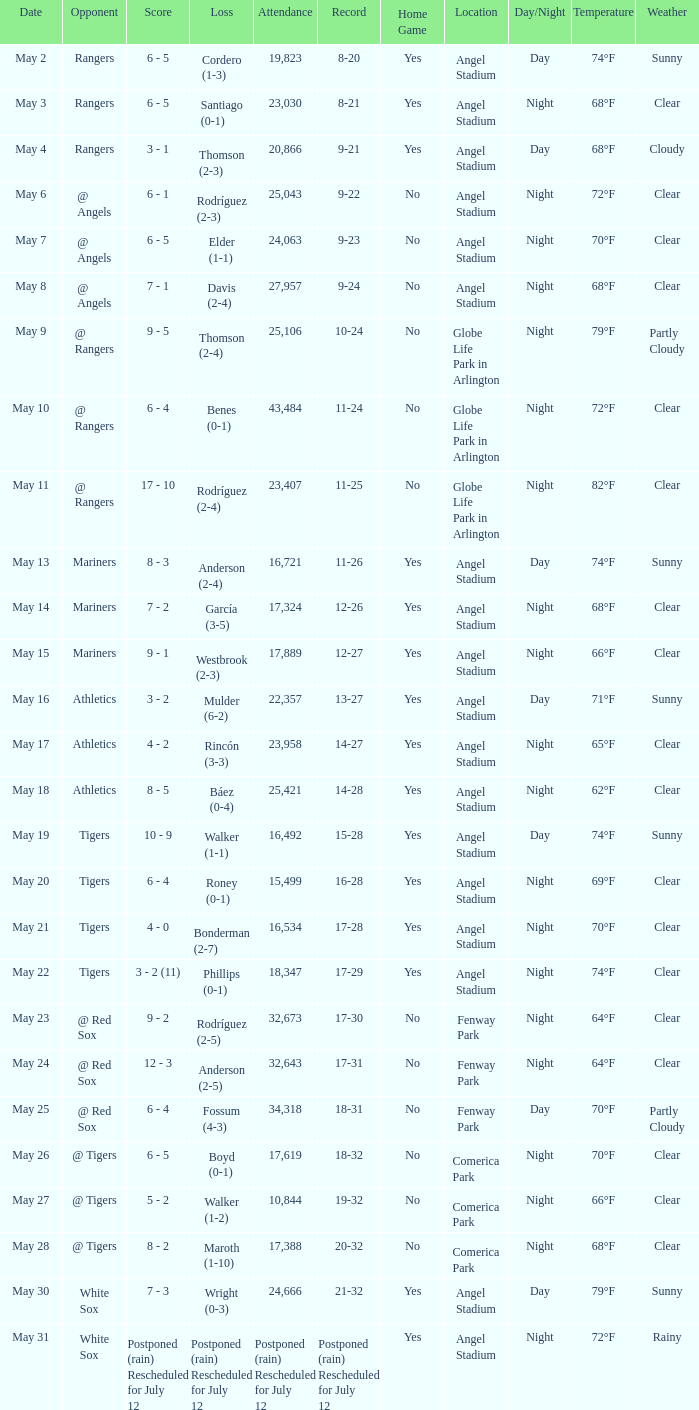What was the Indians record during the game that had 19,823 fans attending? 8-20. 